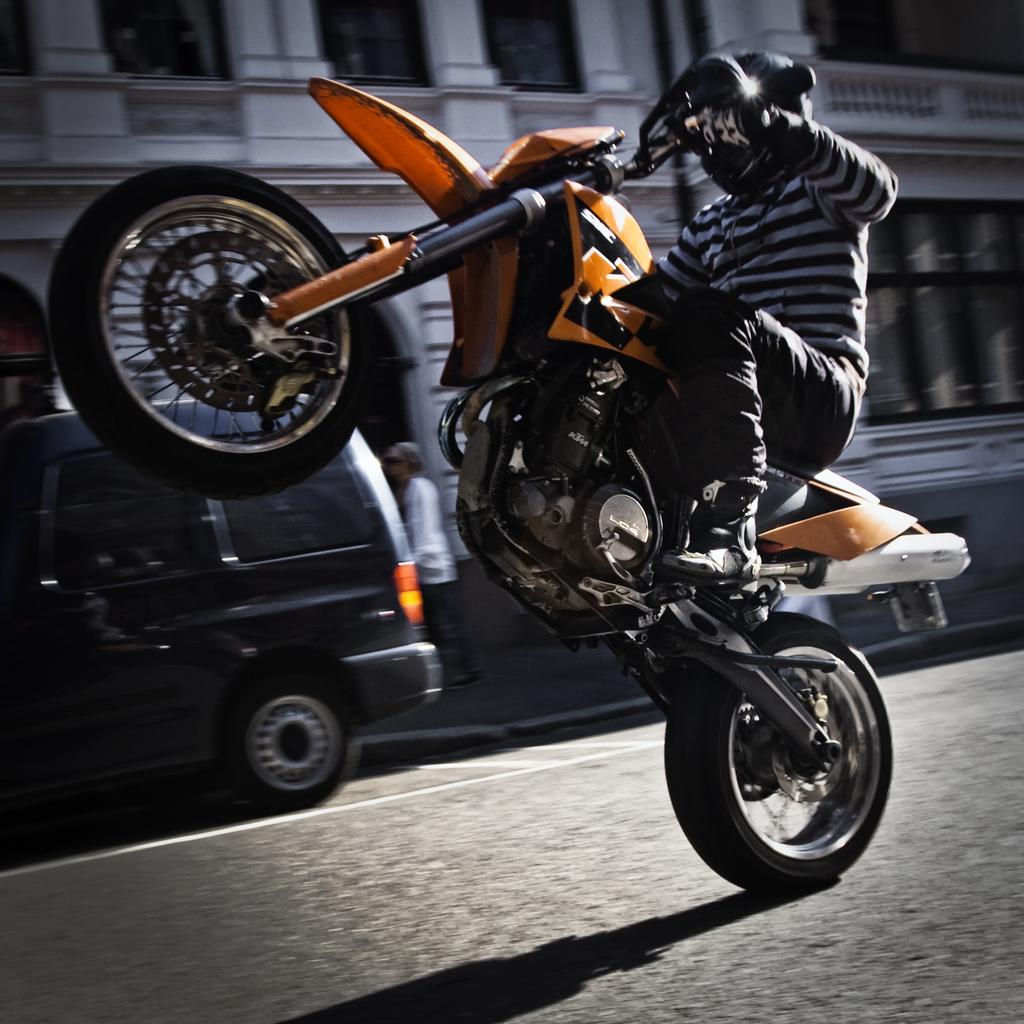What is the person in the image doing with his motorcycle? The person is lifting his motorcycle and riding it. What can be seen in the background of the image? There is a building visible in the image. How many vehicles are present in the image? There is at least one vehicle in the image, which is the motorcycle. Can you describe the other person in the image? There is a person standing in the image. What type of vest is the person wearing while riding the motorcycle? There is no vest visible in the image; the person is wearing a helmet and regular clothing. What punishment is the person receiving for riding the motorcycle in the image? There is no indication of any punishment in the image; the person is simply riding his motorcycle. 